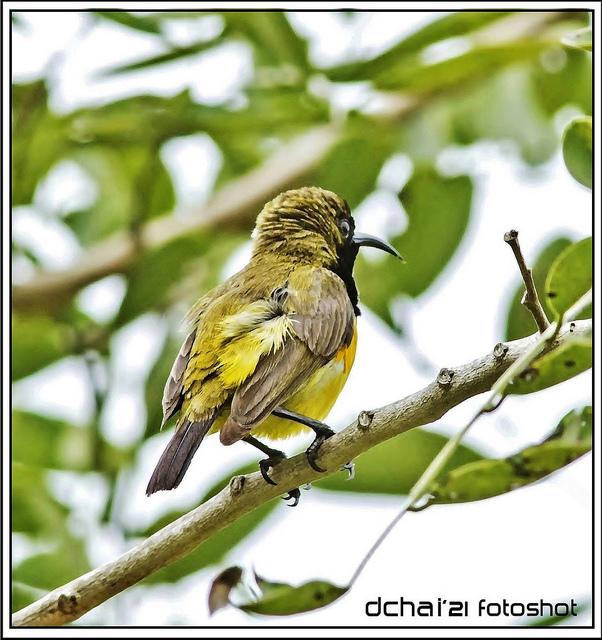What color is the bird's beak?
Keep it brief. Black. Can this animal fly?
Give a very brief answer. Yes. Is this a hungry finch?
Keep it brief. Yes. 